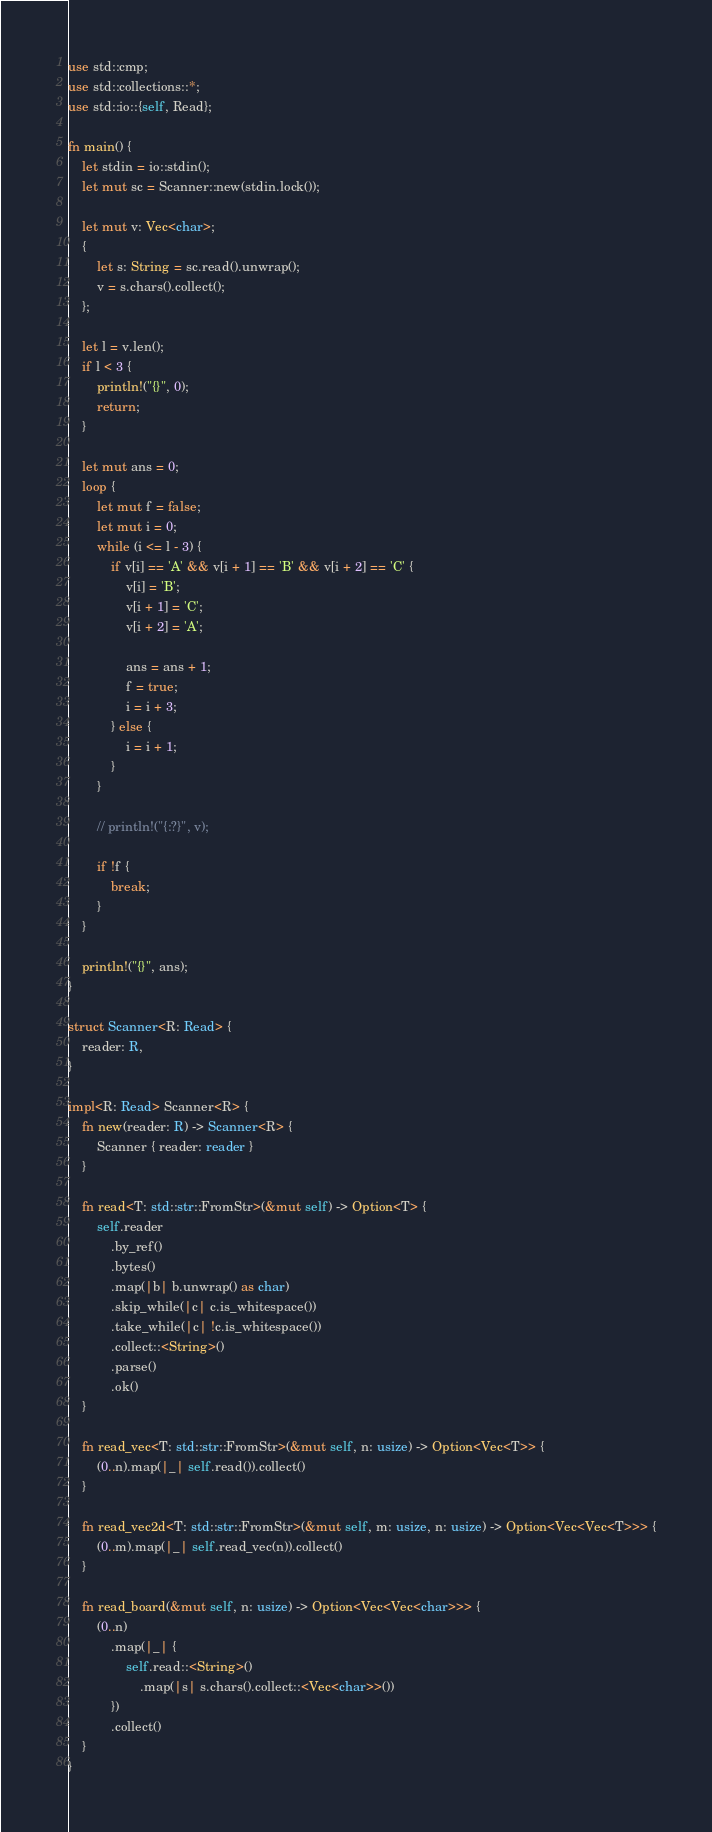<code> <loc_0><loc_0><loc_500><loc_500><_Rust_>use std::cmp;
use std::collections::*;
use std::io::{self, Read};

fn main() {
    let stdin = io::stdin();
    let mut sc = Scanner::new(stdin.lock());

    let mut v: Vec<char>;
    {
        let s: String = sc.read().unwrap();
        v = s.chars().collect();
    };

    let l = v.len();
    if l < 3 {
        println!("{}", 0);
        return;
    }

    let mut ans = 0;
    loop {
        let mut f = false;
        let mut i = 0;
        while (i <= l - 3) {
            if v[i] == 'A' && v[i + 1] == 'B' && v[i + 2] == 'C' {
                v[i] = 'B';
                v[i + 1] = 'C';
                v[i + 2] = 'A';

                ans = ans + 1;
                f = true;
                i = i + 3;
            } else {
                i = i + 1;
            }
        }

        // println!("{:?}", v);

        if !f {
            break;
        }
    }

    println!("{}", ans);
}

struct Scanner<R: Read> {
    reader: R,
}

impl<R: Read> Scanner<R> {
    fn new(reader: R) -> Scanner<R> {
        Scanner { reader: reader }
    }

    fn read<T: std::str::FromStr>(&mut self) -> Option<T> {
        self.reader
            .by_ref()
            .bytes()
            .map(|b| b.unwrap() as char)
            .skip_while(|c| c.is_whitespace())
            .take_while(|c| !c.is_whitespace())
            .collect::<String>()
            .parse()
            .ok()
    }

    fn read_vec<T: std::str::FromStr>(&mut self, n: usize) -> Option<Vec<T>> {
        (0..n).map(|_| self.read()).collect()
    }

    fn read_vec2d<T: std::str::FromStr>(&mut self, m: usize, n: usize) -> Option<Vec<Vec<T>>> {
        (0..m).map(|_| self.read_vec(n)).collect()
    }

    fn read_board(&mut self, n: usize) -> Option<Vec<Vec<char>>> {
        (0..n)
            .map(|_| {
                self.read::<String>()
                    .map(|s| s.chars().collect::<Vec<char>>())
            })
            .collect()
    }
}
</code> 